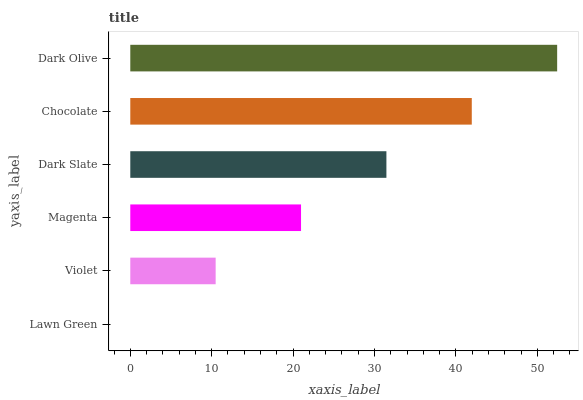Is Lawn Green the minimum?
Answer yes or no. Yes. Is Dark Olive the maximum?
Answer yes or no. Yes. Is Violet the minimum?
Answer yes or no. No. Is Violet the maximum?
Answer yes or no. No. Is Violet greater than Lawn Green?
Answer yes or no. Yes. Is Lawn Green less than Violet?
Answer yes or no. Yes. Is Lawn Green greater than Violet?
Answer yes or no. No. Is Violet less than Lawn Green?
Answer yes or no. No. Is Dark Slate the high median?
Answer yes or no. Yes. Is Magenta the low median?
Answer yes or no. Yes. Is Magenta the high median?
Answer yes or no. No. Is Dark Olive the low median?
Answer yes or no. No. 